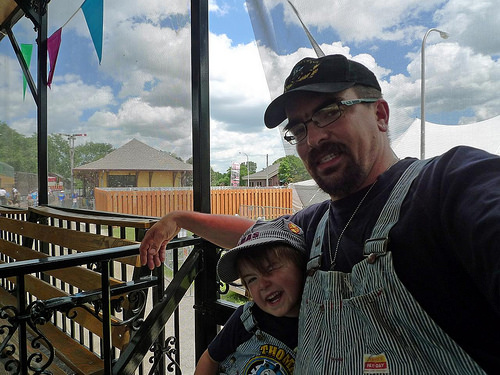<image>
Is there a roof above the cap? No. The roof is not positioned above the cap. The vertical arrangement shows a different relationship. 